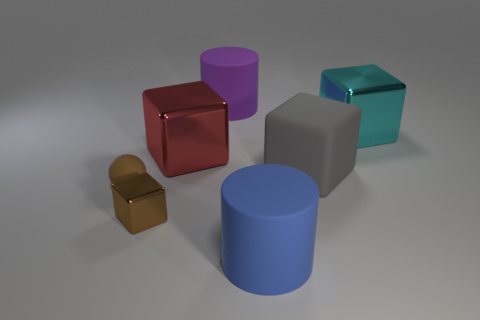Subtract all cyan balls. Subtract all gray cubes. How many balls are left? 1 Add 2 large blue cylinders. How many objects exist? 9 Subtract all cubes. How many objects are left? 3 Add 6 red blocks. How many red blocks exist? 7 Subtract 0 gray cylinders. How many objects are left? 7 Subtract all big green blocks. Subtract all large cyan metal objects. How many objects are left? 6 Add 2 cyan things. How many cyan things are left? 3 